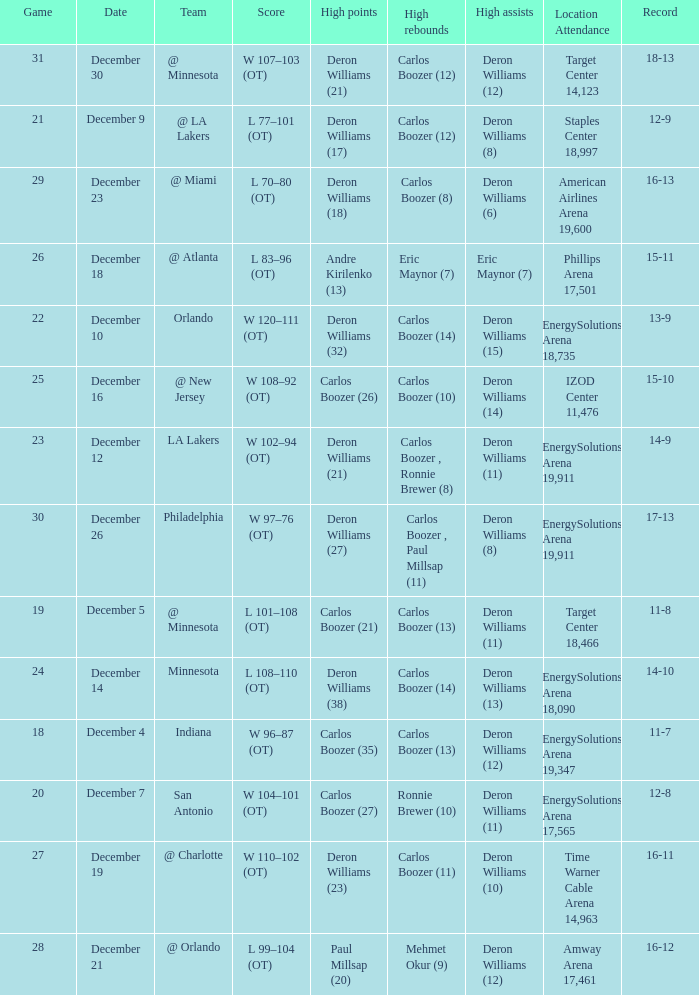How many different high rebound results are there for the game number 26? 1.0. 